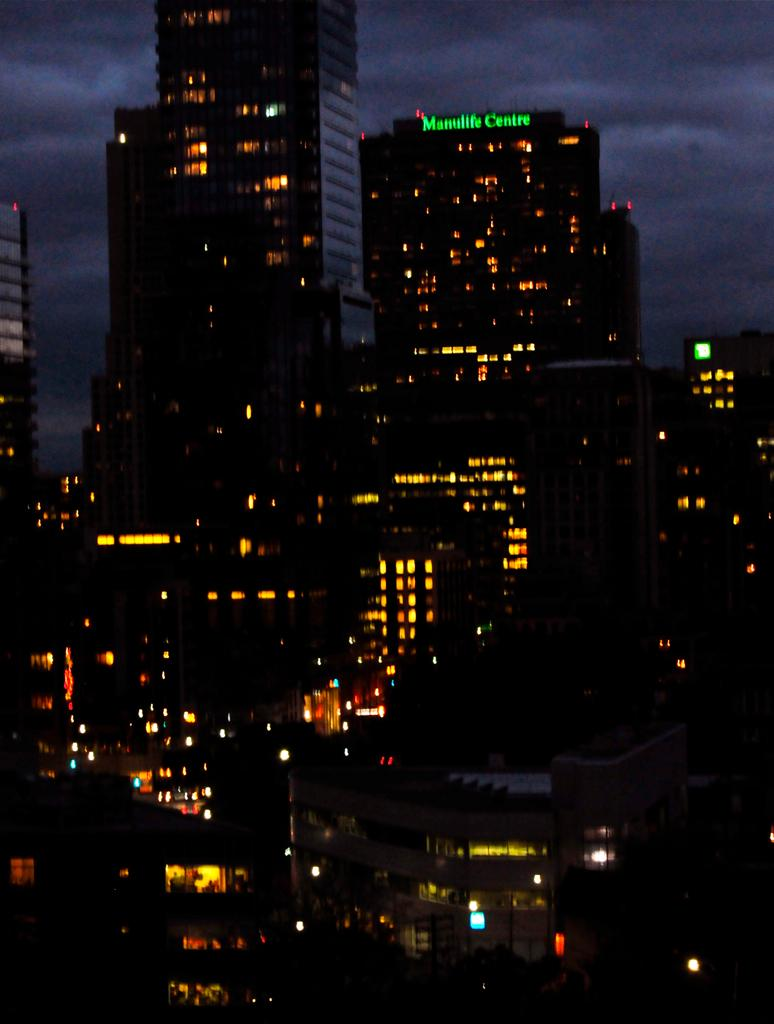What structures are present in the image? There are buildings in the image. What can be seen in the background of the image? There are clouds visible in the background of the image. What part of the natural environment is visible in the image? The sky is visible in the background of the image. How many cars can be seen parked near the buildings in the image? There is no mention of cars in the image; only buildings, clouds, and the sky are present. Is there a beggar visible in the image? There is no indication of a beggar in the image. 